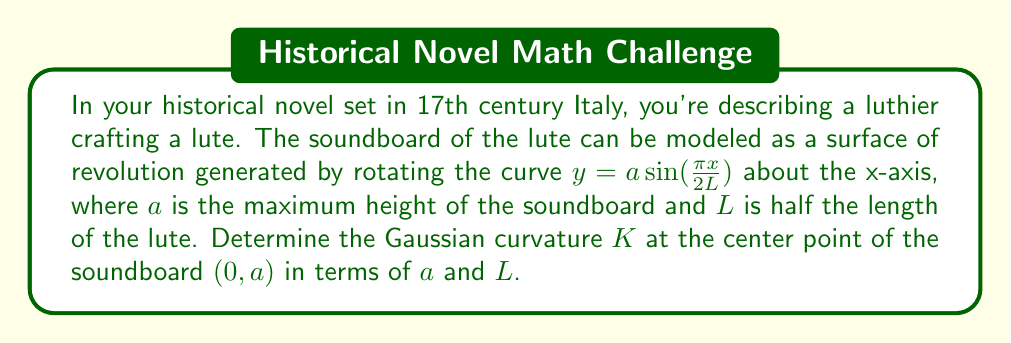What is the answer to this math problem? To solve this problem, we'll use differential geometry techniques:

1) First, we parametrize the surface. Let $r(u,v)$ be our parametrization:

   $$r(u,v) = (u, a\sin(\frac{\pi u}{2L})\cos v, a\sin(\frac{\pi u}{2L})\sin v)$$

   where $-L \leq u \leq L$ and $0 \leq v < 2\pi$.

2) We need to calculate the first and second fundamental forms. Let's start with the partial derivatives:

   $$r_u = (1, \frac{a\pi}{2L}\cos(\frac{\pi u}{2L})\cos v, \frac{a\pi}{2L}\cos(\frac{\pi u}{2L})\sin v)$$
   $$r_v = (0, -a\sin(\frac{\pi u}{2L})\sin v, a\sin(\frac{\pi u}{2L})\cos v)$$

3) The coefficients of the first fundamental form are:

   $$E = r_u \cdot r_u = 1 + (\frac{a\pi}{2L})^2\cos^2(\frac{\pi u}{2L})$$
   $$F = r_u \cdot r_v = 0$$
   $$G = r_v \cdot r_v = a^2\sin^2(\frac{\pi u}{2L})$$

4) For the second fundamental form, we need the second partial derivatives:

   $$r_{uu} = (0, -\frac{a\pi^2}{4L^2}\sin(\frac{\pi u}{2L})\cos v, -\frac{a\pi^2}{4L^2}\sin(\frac{\pi u}{2L})\sin v)$$
   $$r_{uv} = (0, -\frac{a\pi}{2L}\cos(\frac{\pi u}{2L})\sin v, \frac{a\pi}{2L}\cos(\frac{\pi u}{2L})\cos v)$$
   $$r_{vv} = (0, -a\sin(\frac{\pi u}{2L})\cos v, -a\sin(\frac{\pi u}{2L})\sin v)$$

5) The unit normal vector is:

   $$N = \frac{r_u \times r_v}{|r_u \times r_v|} = \frac{(-\frac{a\pi}{2L}\cos(\frac{\pi u}{2L}), \cos v, \sin v)}{\sqrt{1 + (\frac{a\pi}{2L})^2\cos^2(\frac{\pi u}{2L})}}$$

6) The coefficients of the second fundamental form are:

   $$L = r_{uu} \cdot N = -\frac{a\pi^2}{4L^2}\sin(\frac{\pi u}{2L}) / \sqrt{1 + (\frac{a\pi}{2L})^2\cos^2(\frac{\pi u}{2L})}$$
   $$M = r_{uv} \cdot N = 0$$
   $$N = r_{vv} \cdot N = -a\sin(\frac{\pi u}{2L}) / \sqrt{1 + (\frac{a\pi}{2L})^2\cos^2(\frac{\pi u}{2L})}$$

7) The Gaussian curvature is given by:

   $$K = \frac{LN - M^2}{EG - F^2}$$

8) At the center point $(0,a)$, $u=0$. Substituting this:

   $$K|_{(0,a)} = \frac{(-\frac{a\pi^2}{4L^2} \cdot 0 - 0) \cdot (1 + (\frac{a\pi}{2L})^2)}{(1 + (\frac{a\pi}{2L})^2) \cdot 0 - 0^2} = 0$$
Answer: The Gaussian curvature $K$ at the center point of the soundboard $(0,a)$ is 0. 